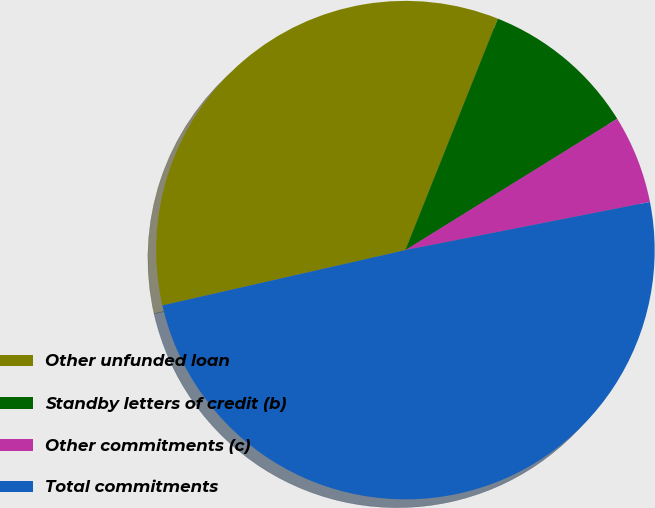<chart> <loc_0><loc_0><loc_500><loc_500><pie_chart><fcel>Other unfunded loan<fcel>Standby letters of credit (b)<fcel>Other commitments (c)<fcel>Total commitments<nl><fcel>34.61%<fcel>10.12%<fcel>5.74%<fcel>49.54%<nl></chart> 